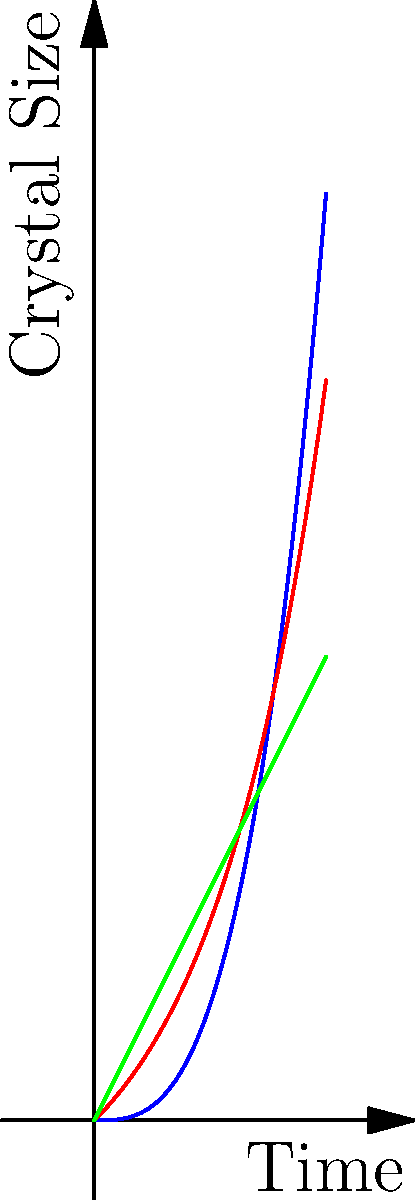As a museum curator, you're developing an educational exhibit on mineral crystallization. The graph shows growth patterns of three different crystalline structures over time. Which growth pattern would you expect to see in a mineral that forms under conditions of rapid, unconstrained growth in a supersaturated solution? To answer this question, let's analyze each growth pattern:

1. Linear growth (green line):
   - Represents steady, constant growth over time
   - Typically seen in controlled environments or limited resource conditions

2. Cubic growth (blue curve):
   - Shows accelerating growth, but at a slower rate than exponential
   - Often observed in more complex crystal systems or those with some growth constraints

3. Exponential growth (red curve):
   - Exhibits rapid, accelerating growth that increases dramatically over time
   - Characteristic of unrestricted growth in ideal conditions

In a supersaturated solution with rapid, unconstrained growth:
- There's an abundance of minerals available for crystal formation
- No significant barriers to growth exist
- The rate of crystal formation increases as more surface area becomes available for mineral deposition

Given these conditions, the exponential growth pattern (red curve) best represents the expected crystal growth. This pattern shows the fastest increase in crystal size over time, consistent with rapid, unconstrained growth in a supersaturated environment.
Answer: Exponential growth pattern 